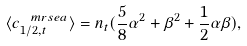Convert formula to latex. <formula><loc_0><loc_0><loc_500><loc_500>\langle c _ { 1 / 2 , t } ^ { \ m r { s e a } } \rangle = n _ { t } ( \frac { 5 } { 8 } \alpha ^ { 2 } + \beta ^ { 2 } + \frac { 1 } { 2 } \alpha \beta ) ,</formula> 